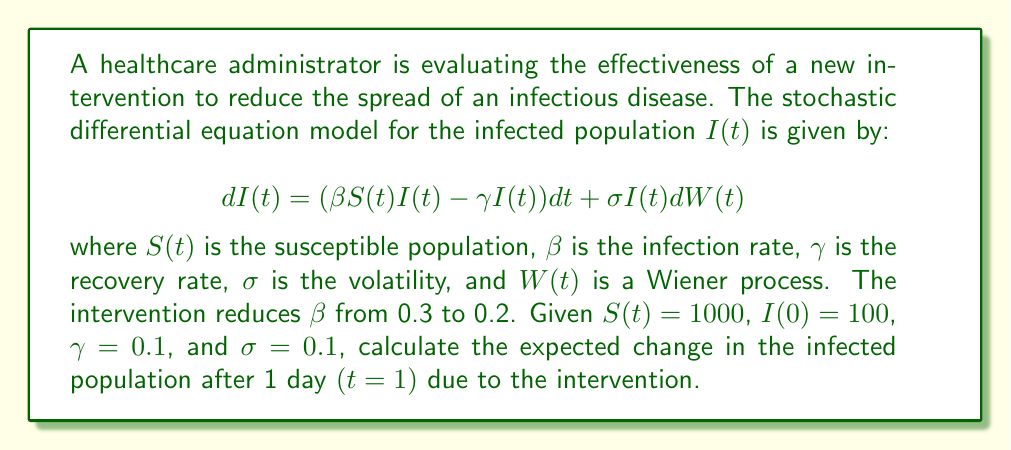Give your solution to this math problem. To solve this problem, we need to follow these steps:

1) The deterministic part of the SDE is given by $(\beta S(t)I(t) - \gamma I(t))dt$. This represents the expected change in the infected population.

2) We need to calculate this for both the original and reduced $\beta$ values:

   For $\beta = 0.3$ (before intervention):
   $$E[dI(t)] = (0.3 \cdot 1000 \cdot 100 - 0.1 \cdot 100)dt = 2900dt$$

   For $\beta = 0.2$ (after intervention):
   $$E[dI(t)] = (0.2 \cdot 1000 \cdot 100 - 0.1 \cdot 100)dt = 1900dt$$

3) To find the expected change over 1 day, we integrate from 0 to 1:

   Before intervention: $\int_0^1 2900 dt = 2900$
   After intervention: $\int_0^1 1900 dt = 1900$

4) The difference between these values gives us the expected change due to the intervention:

   $2900 - 1900 = 1000$

Therefore, the intervention is expected to reduce the growth of the infected population by 1000 individuals after 1 day.
Answer: 1000 